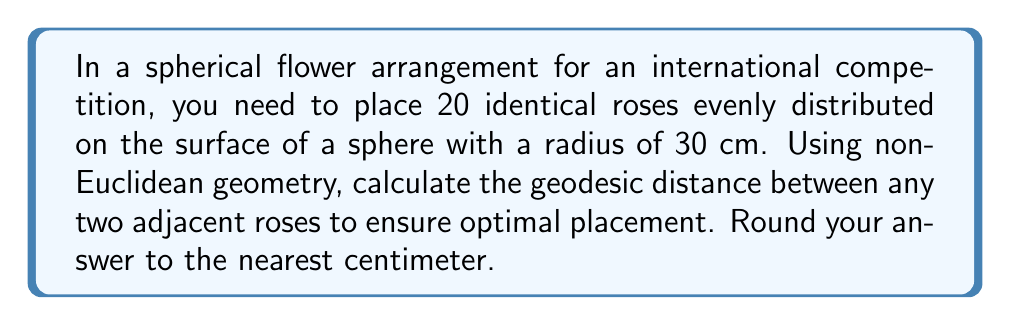Show me your answer to this math problem. Let's approach this step-by-step:

1) In a spherical arrangement, the optimal distribution of points is achieved through the concept of spherical packing. The best approximation for 20 points on a sphere is the vertices of a regular dodecahedron.

2) A regular dodecahedron has 20 vertices, 30 edges, and 12 faces. The roses will be placed at these vertices.

3) The surface area of a sphere is given by the formula:
   $$A = 4\pi r^2$$
   Where $r$ is the radius of the sphere.

4) Substituting $r = 30$ cm:
   $$A = 4\pi (30)^2 = 11,309.73 \text{ cm}^2$$

5) The surface area of each spherical triangle (formed by adjacent roses) is:
   $$A_{triangle} = \frac{11,309.73}{60} = 188.50 \text{ cm}^2$$
   (There are 60 congruent spherical triangles in a regular dodecahedron)

6) The spherical excess $E$ of each triangle is given by:
   $$E = \frac{A_{triangle}}{r^2} = \frac{188.50}{30^2} = 0.2094 \text{ radians}$$

7) In a spherical triangle, the spherical excess is related to the interior angles $\alpha$, $\beta$, and $\gamma$ by:
   $$E = \alpha + \beta + \gamma - \pi$$

8) In our regular spherical triangle, all angles are equal. Let's call this angle $\theta$. Then:
   $$0.2094 = 3\theta - \pi$$
   $$\theta = \frac{0.2094 + \pi}{3} = 1.1165 \text{ radians}$$

9) Now, we can use the spherical law of cosines to find the side length $a$ (which is the geodesic distance we're looking for):
   $$\cos(a) = \frac{\cos(\theta) + \cos(\theta)\cos(\theta)}{\sin(\theta)\sin(\theta)}$$

10) Substituting and solving:
    $$a = \arccos(\frac{\cos(1.1165) + \cos(1.1165)\cos(1.1165)}{\sin(1.1165)\sin(1.1165)})$$
    $$a = 1.0472 \text{ radians}$$

11) Converting to centimeters (remember, this is an arc length on a sphere with radius 30 cm):
    $$\text{Distance} = 30 * 1.0472 = 31.42 \text{ cm}$$

12) Rounding to the nearest centimeter:
    $$\text{Distance} \approx 31 \text{ cm}$$
Answer: 31 cm 